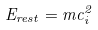<formula> <loc_0><loc_0><loc_500><loc_500>E _ { r e s t } = m c _ { i } ^ { 2 }</formula> 